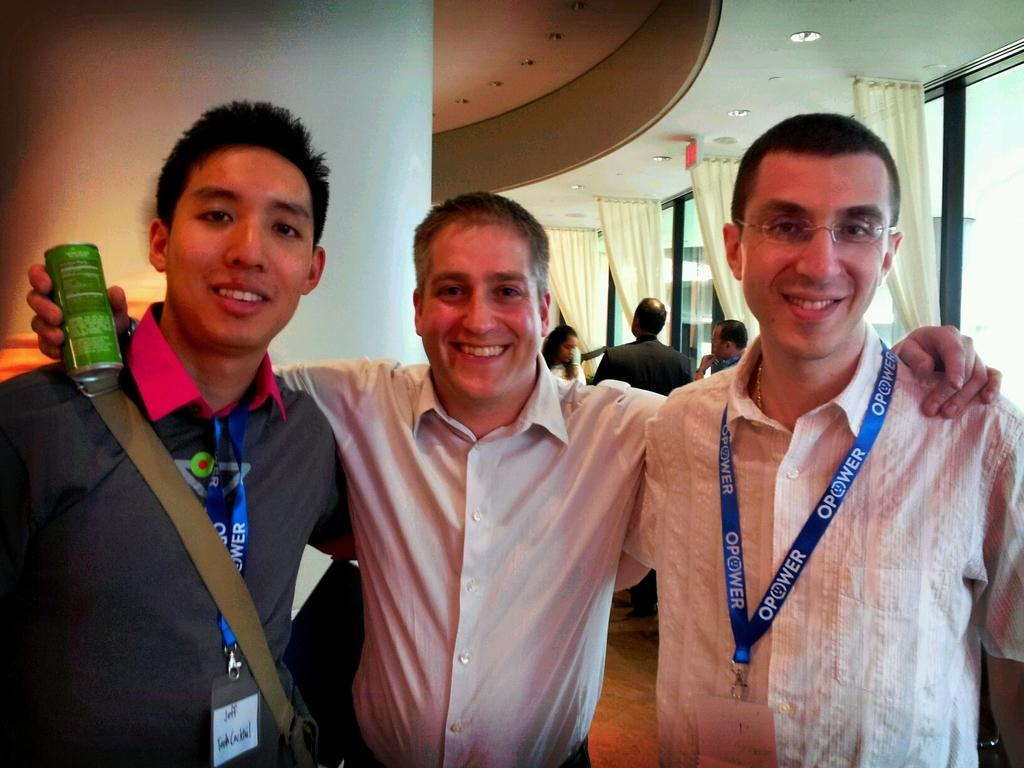<image>
Present a compact description of the photo's key features. Three men posing for a photo, two wearing Opower lanyards. 